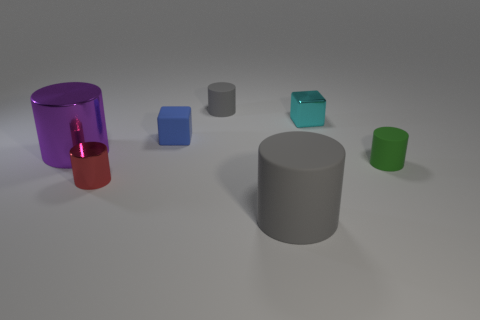Subtract 4 cylinders. How many cylinders are left? 1 Subtract all large gray rubber cylinders. How many cylinders are left? 4 Add 1 gray cylinders. How many objects exist? 8 Subtract all cubes. How many objects are left? 5 Subtract all purple spheres. How many blue blocks are left? 1 Subtract all red shiny cylinders. Subtract all rubber cylinders. How many objects are left? 3 Add 7 small cyan things. How many small cyan things are left? 8 Add 3 big brown shiny spheres. How many big brown shiny spheres exist? 3 Subtract all cyan cubes. How many cubes are left? 1 Subtract 0 red blocks. How many objects are left? 7 